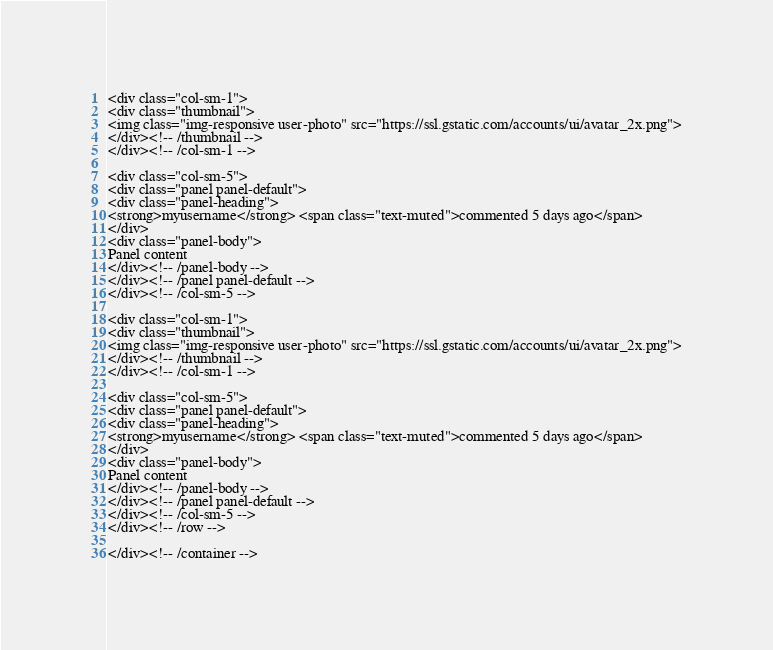Convert code to text. <code><loc_0><loc_0><loc_500><loc_500><_PHP_><div class="col-sm-1">
<div class="thumbnail">
<img class="img-responsive user-photo" src="https://ssl.gstatic.com/accounts/ui/avatar_2x.png">
</div><!-- /thumbnail -->
</div><!-- /col-sm-1 -->

<div class="col-sm-5">
<div class="panel panel-default">
<div class="panel-heading">
<strong>myusername</strong> <span class="text-muted">commented 5 days ago</span>
</div>
<div class="panel-body">
Panel content
</div><!-- /panel-body -->
</div><!-- /panel panel-default -->
</div><!-- /col-sm-5 -->

<div class="col-sm-1">
<div class="thumbnail">
<img class="img-responsive user-photo" src="https://ssl.gstatic.com/accounts/ui/avatar_2x.png">
</div><!-- /thumbnail -->
</div><!-- /col-sm-1 -->

<div class="col-sm-5">
<div class="panel panel-default">
<div class="panel-heading">
<strong>myusername</strong> <span class="text-muted">commented 5 days ago</span>
</div>
<div class="panel-body">
Panel content
</div><!-- /panel-body -->
</div><!-- /panel panel-default -->
</div><!-- /col-sm-5 -->
</div><!-- /row -->

</div><!-- /container -->

</code> 